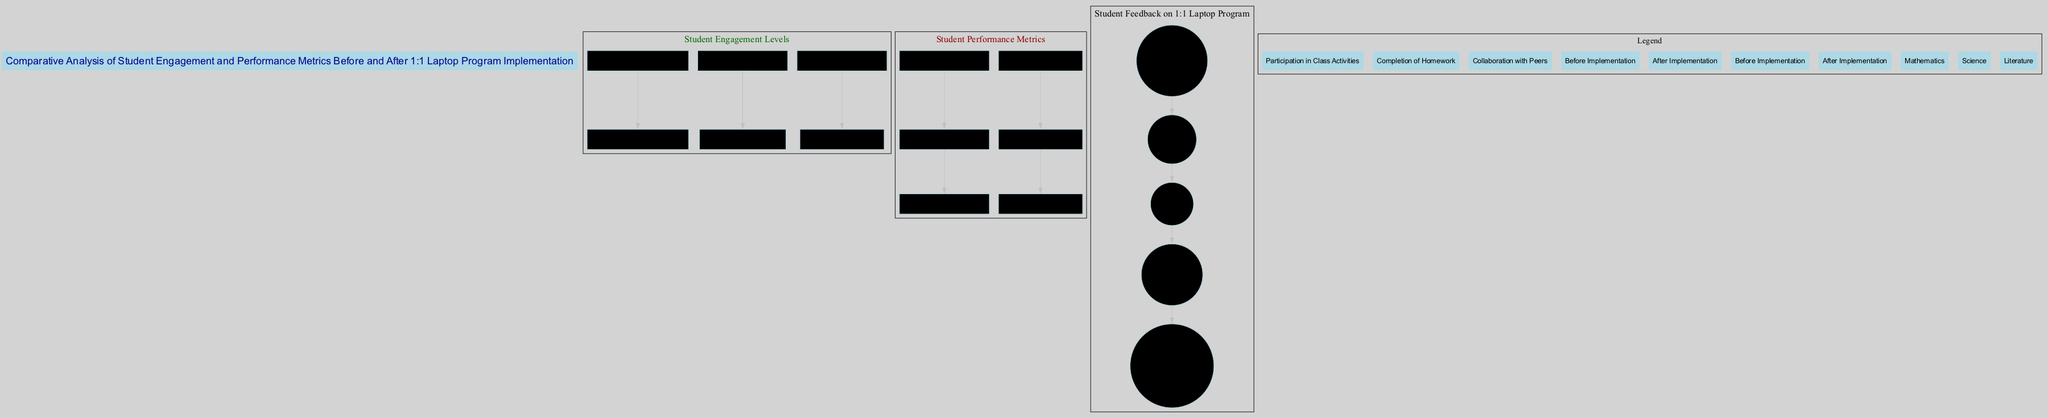What is the engagement score for "Completion of Homework" after implementation? According to the bar graph under "Student Engagement Levels", the score for "Completion of Homework" after the implementation is indicated as 90.
Answer: 90 What was the average score in Mathematics before implementation? In the "Student Performance Metrics" bar graph, the average score for Mathematics before implementation is shown as 70.
Answer: 70 Which category had the highest engagement score after implementation? By comparing the values in the "Student Engagement Levels" bar graph after implementation, "Completion of Homework" has the highest score at 90.
Answer: Completion of Homework What percentage of students were "Very Satisfied" with the 1:1 laptop program? The pie chart for "Student Feedback on 1:1 Laptop Program" indicates that 45 out of 100 students were "Very Satisfied", which is 45%.
Answer: 45% How much did the student engagement level for "Collaboration with Peers" change after implementation? The score for "Collaboration with Peers" went from 40 before implementation to 80 after implementation, which is an increase of 40.
Answer: 40 What is the average score in Literature after the implementation? In the "Student Performance Metrics" bar graph, the average score for Literature after implementation is presented as 78.
Answer: 78 Which subject showed the least improvement in average score after the implementation? By analyzing the average scores before and after for all subjects, Science showed the least improvement, from 75 to 80, which is a 5-point increase.
Answer: Science What was the total number of feedback categories shown in the pie chart? The pie chart lists five categories of student feedback: "Very Satisfied", "Satisfied", "Neutral", "Dissatisfied", and "Very Dissatisfied", indicating a total of five categories.
Answer: 5 How many students reported being Neutral in their feedback on the 1:1 laptop program? According to the pie chart, 15 students expressed Neutral feedback regarding the laptop program.
Answer: 15 